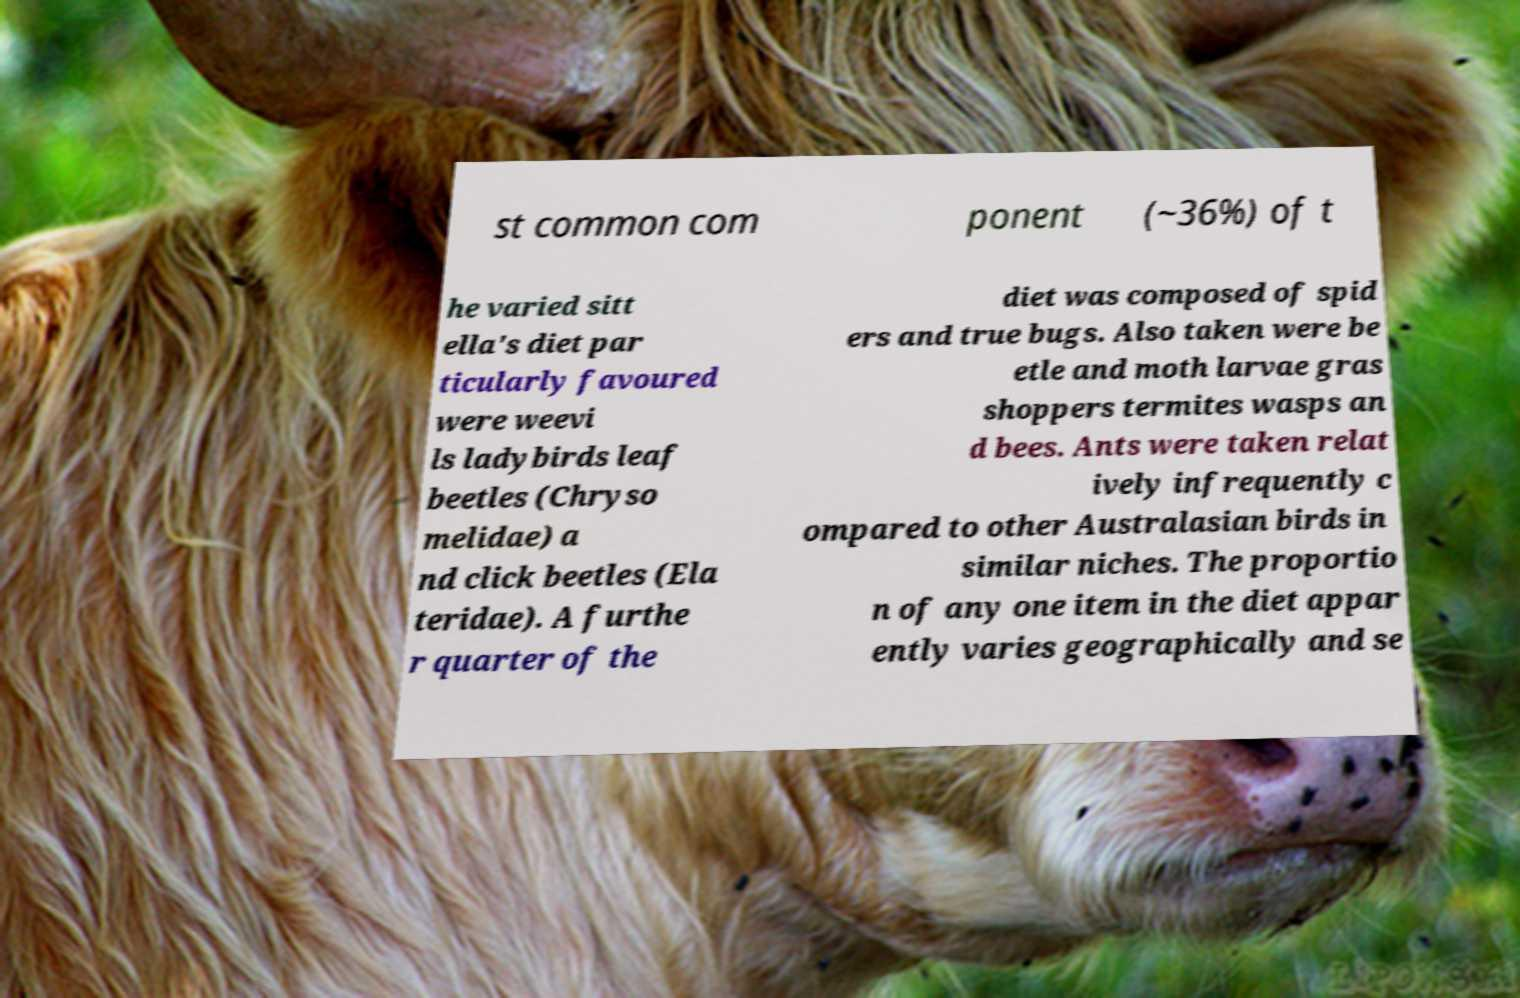Could you assist in decoding the text presented in this image and type it out clearly? st common com ponent (~36%) of t he varied sitt ella's diet par ticularly favoured were weevi ls ladybirds leaf beetles (Chryso melidae) a nd click beetles (Ela teridae). A furthe r quarter of the diet was composed of spid ers and true bugs. Also taken were be etle and moth larvae gras shoppers termites wasps an d bees. Ants were taken relat ively infrequently c ompared to other Australasian birds in similar niches. The proportio n of any one item in the diet appar ently varies geographically and se 